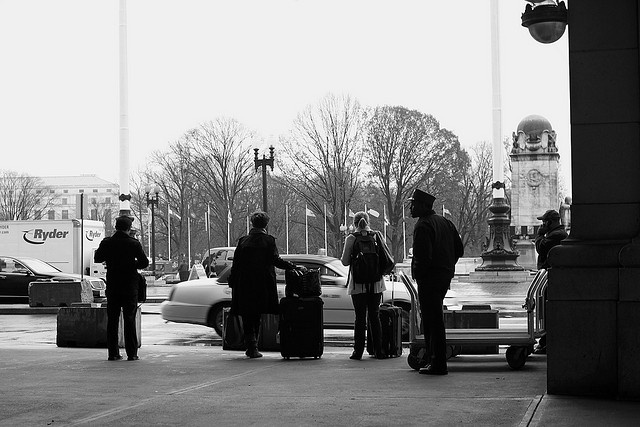Describe the objects in this image and their specific colors. I can see car in white, gray, black, darkgray, and lightgray tones, people in white, black, gray, lightgray, and darkgray tones, people in white, black, gray, darkgray, and lightgray tones, truck in white, lightgray, darkgray, gray, and black tones, and people in white, black, gray, darkgray, and lightgray tones in this image. 